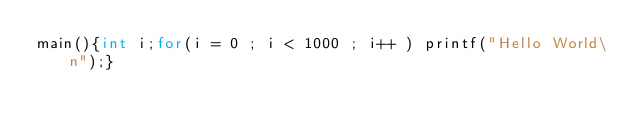Convert code to text. <code><loc_0><loc_0><loc_500><loc_500><_C_>main(){int i;for(i = 0 ; i < 1000 ; i++ ) printf("Hello World\n");}</code> 